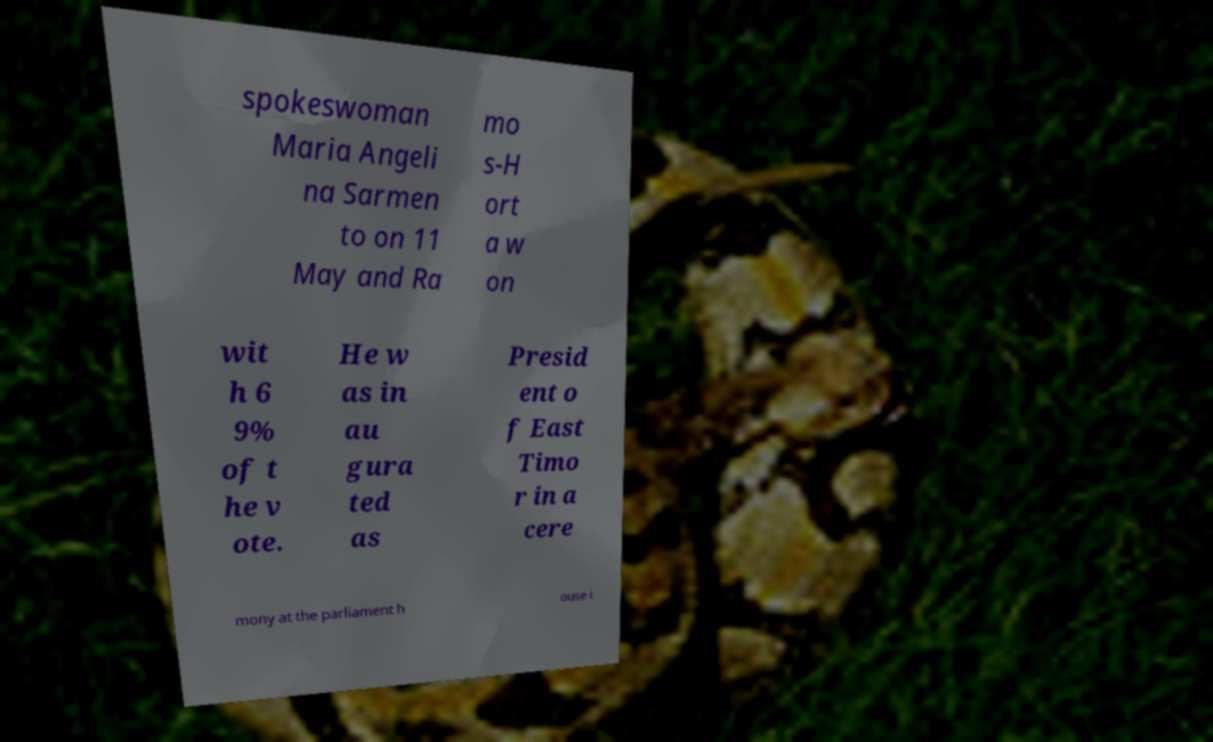Could you assist in decoding the text presented in this image and type it out clearly? spokeswoman Maria Angeli na Sarmen to on 11 May and Ra mo s-H ort a w on wit h 6 9% of t he v ote. He w as in au gura ted as Presid ent o f East Timo r in a cere mony at the parliament h ouse i 